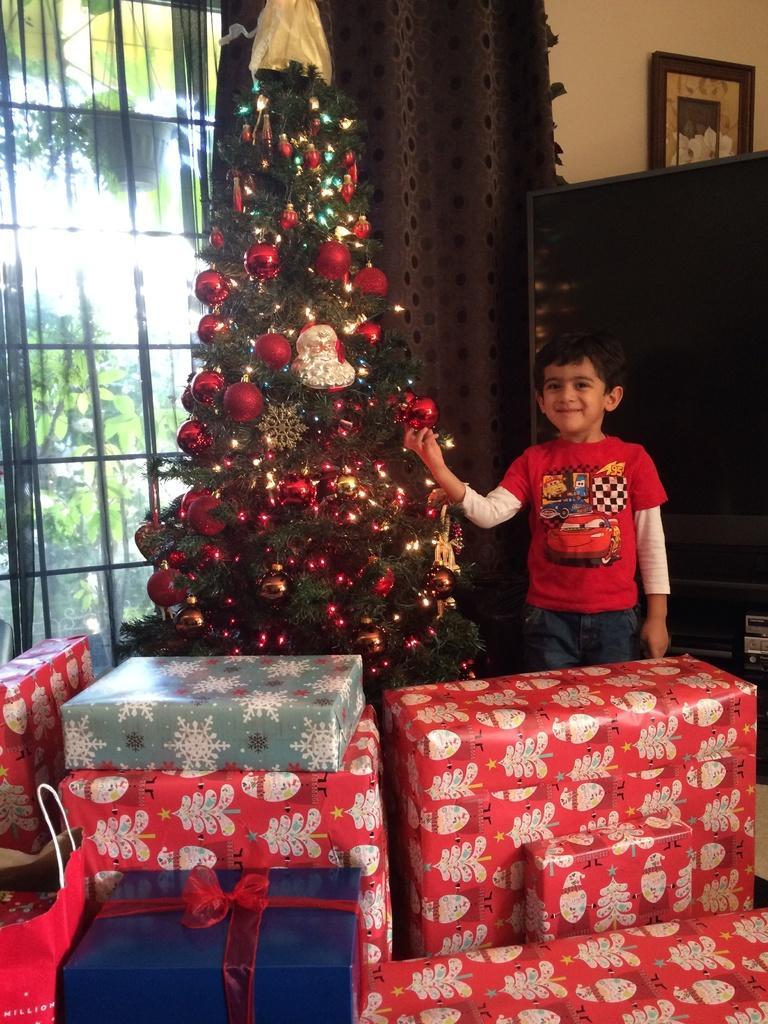Please provide a concise description of this image. There is a Christmas tree and a boy standing beside a tree, there are a lot of gifts kept in front of the tree and behind the boy there is a window and there is a curtain beside the window, in the background there a sky and a lot of plants behind the window. 